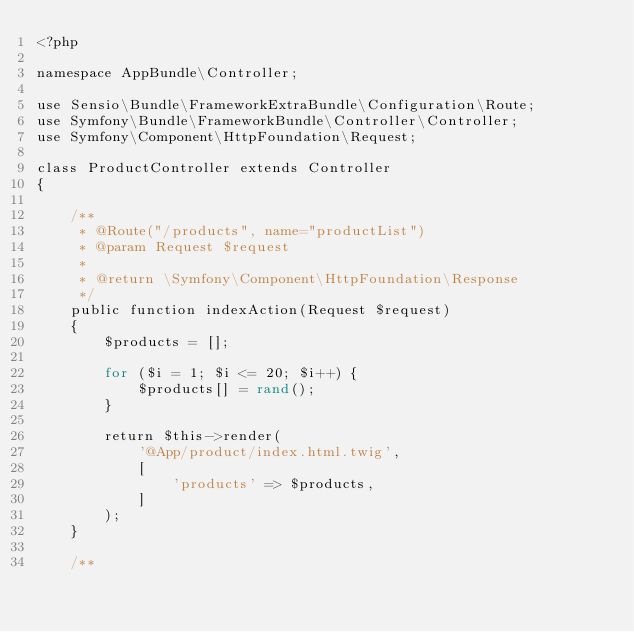<code> <loc_0><loc_0><loc_500><loc_500><_PHP_><?php

namespace AppBundle\Controller;

use Sensio\Bundle\FrameworkExtraBundle\Configuration\Route;
use Symfony\Bundle\FrameworkBundle\Controller\Controller;
use Symfony\Component\HttpFoundation\Request;

class ProductController extends Controller
{

    /**
     * @Route("/products", name="productList")
     * @param Request $request
     *
     * @return \Symfony\Component\HttpFoundation\Response
     */
    public function indexAction(Request $request)
    {
        $products = [];

        for ($i = 1; $i <= 20; $i++) {
            $products[] = rand();
        }

        return $this->render(
            '@App/product/index.html.twig',
            [
                'products' => $products,
            ]
        );
    }

    /**</code> 